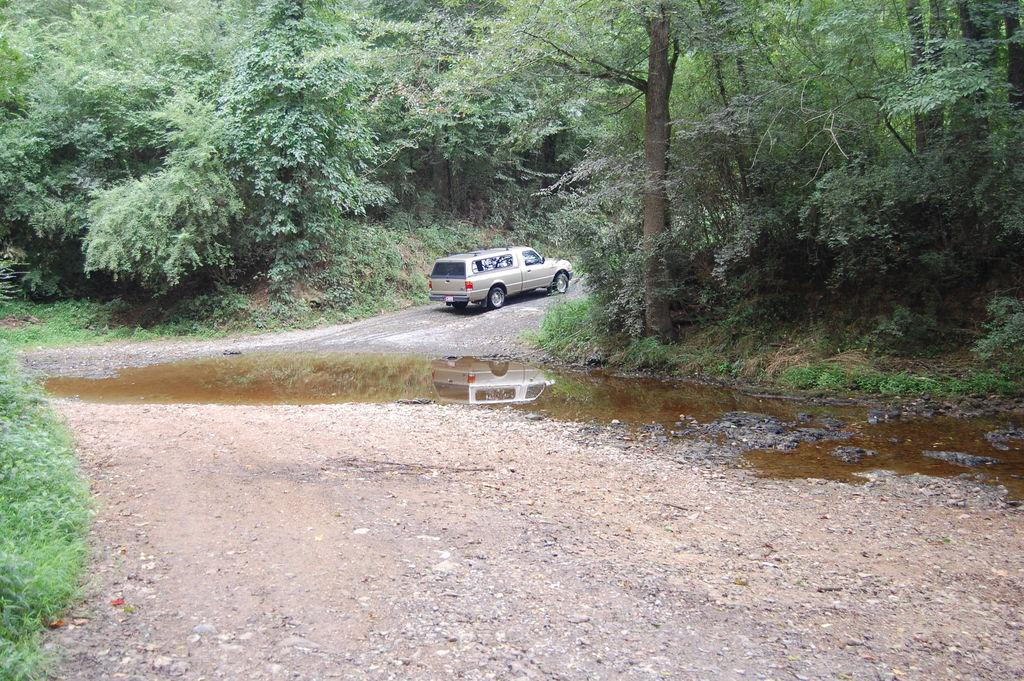What type of natural elements can be seen in the image? There are trees and plants visible in the image. What is the water feature in the image? There is water visible in the image. What type of terrain is present in the image? There is sand in the image. What type of man-made structure is present in the image? There is a vehicle on the road in the image. What scientific experiment is being conducted in the image? There is no scientific experiment being conducted in the image. What type of train can be seen passing through the image? There is no train present in the image. 